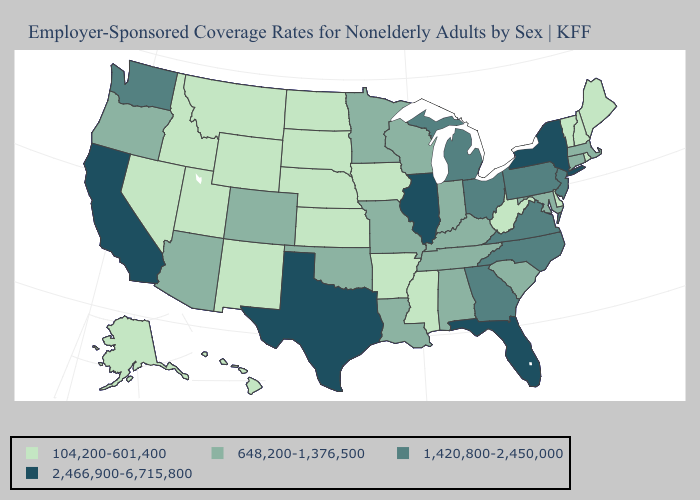What is the value of Washington?
Write a very short answer. 1,420,800-2,450,000. Name the states that have a value in the range 648,200-1,376,500?
Be succinct. Alabama, Arizona, Colorado, Connecticut, Indiana, Kentucky, Louisiana, Maryland, Massachusetts, Minnesota, Missouri, Oklahoma, Oregon, South Carolina, Tennessee, Wisconsin. What is the highest value in the USA?
Quick response, please. 2,466,900-6,715,800. What is the value of Maryland?
Give a very brief answer. 648,200-1,376,500. What is the lowest value in states that border South Dakota?
Keep it brief. 104,200-601,400. What is the value of West Virginia?
Quick response, please. 104,200-601,400. What is the value of Mississippi?
Give a very brief answer. 104,200-601,400. Does New Mexico have the lowest value in the USA?
Concise answer only. Yes. What is the value of Texas?
Concise answer only. 2,466,900-6,715,800. What is the value of Georgia?
Write a very short answer. 1,420,800-2,450,000. Name the states that have a value in the range 648,200-1,376,500?
Concise answer only. Alabama, Arizona, Colorado, Connecticut, Indiana, Kentucky, Louisiana, Maryland, Massachusetts, Minnesota, Missouri, Oklahoma, Oregon, South Carolina, Tennessee, Wisconsin. Does the first symbol in the legend represent the smallest category?
Short answer required. Yes. How many symbols are there in the legend?
Keep it brief. 4. Which states hav the highest value in the MidWest?
Answer briefly. Illinois. What is the highest value in the Northeast ?
Quick response, please. 2,466,900-6,715,800. 